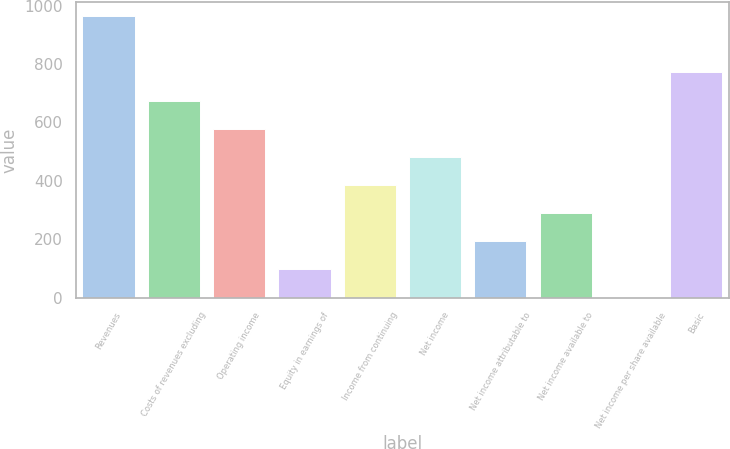<chart> <loc_0><loc_0><loc_500><loc_500><bar_chart><fcel>Revenues<fcel>Costs of revenues excluding<fcel>Operating income<fcel>Equity in earnings of<fcel>Income from continuing<fcel>Net income<fcel>Net income attributable to<fcel>Net income available to<fcel>Net income per share available<fcel>Basic<nl><fcel>964<fcel>674.88<fcel>578.52<fcel>96.72<fcel>385.8<fcel>482.16<fcel>193.08<fcel>289.44<fcel>0.36<fcel>771.24<nl></chart> 